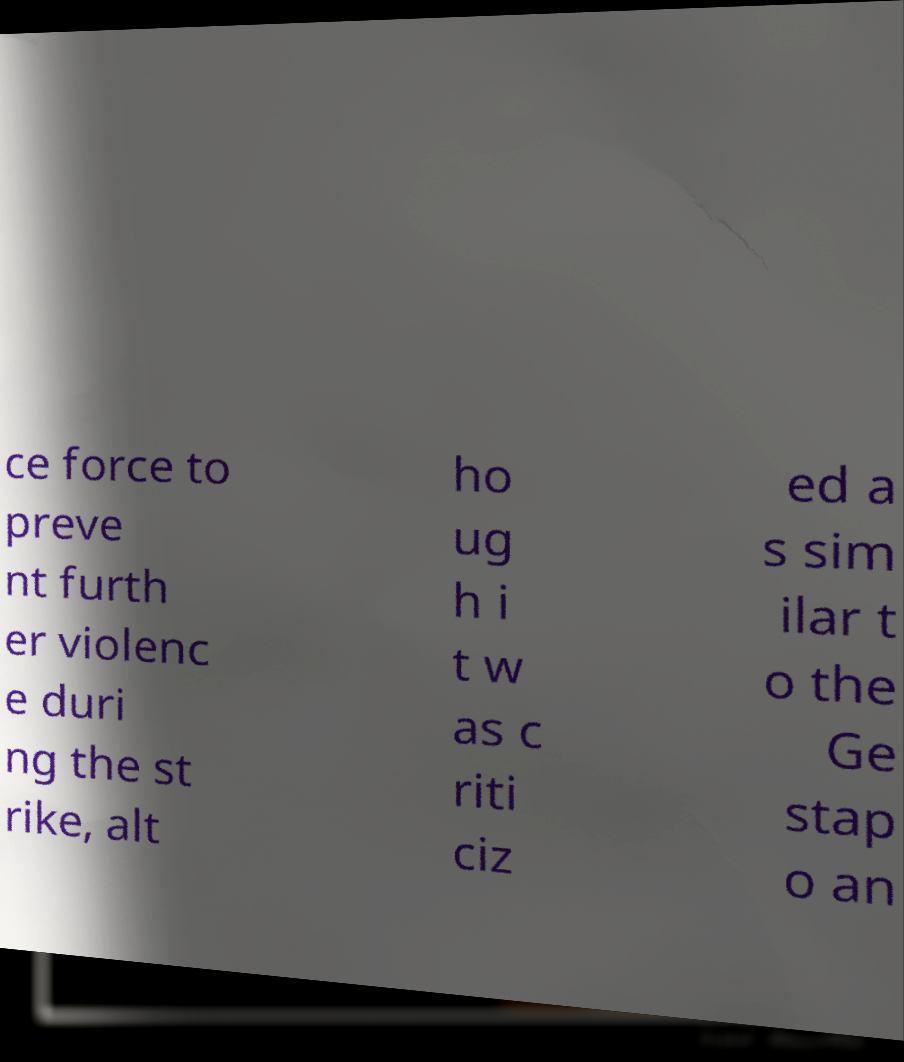I need the written content from this picture converted into text. Can you do that? ce force to preve nt furth er violenc e duri ng the st rike, alt ho ug h i t w as c riti ciz ed a s sim ilar t o the Ge stap o an 